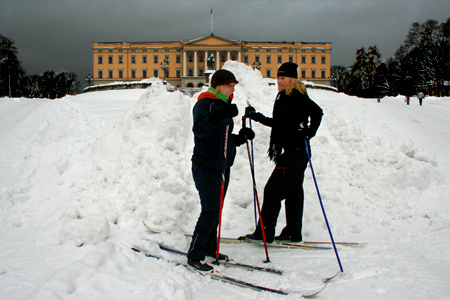Which color is the sky? The sky appears to be dark. 